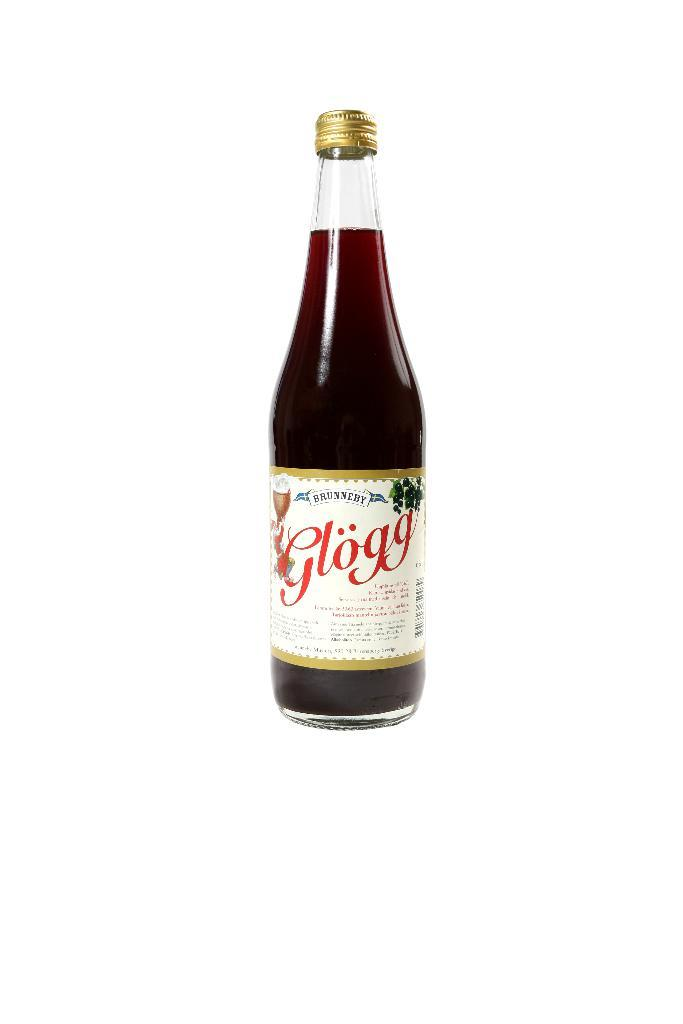<image>
Create a compact narrative representing the image presented. bottle of brunneby glogg and it has a twist off cap 